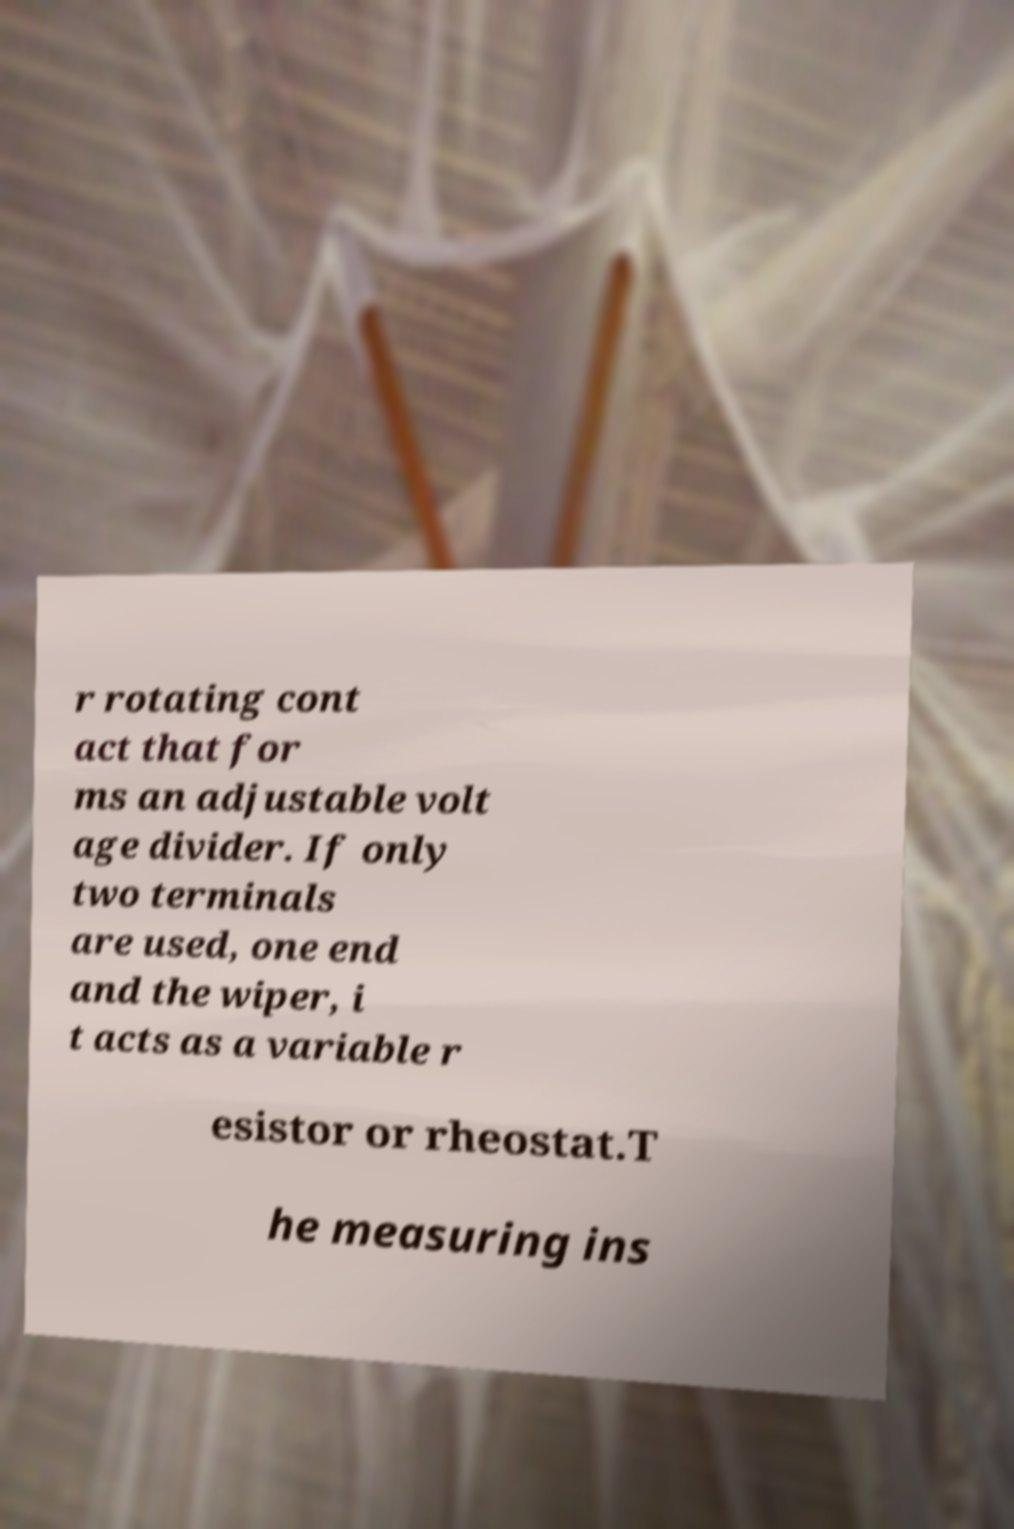Could you extract and type out the text from this image? r rotating cont act that for ms an adjustable volt age divider. If only two terminals are used, one end and the wiper, i t acts as a variable r esistor or rheostat.T he measuring ins 